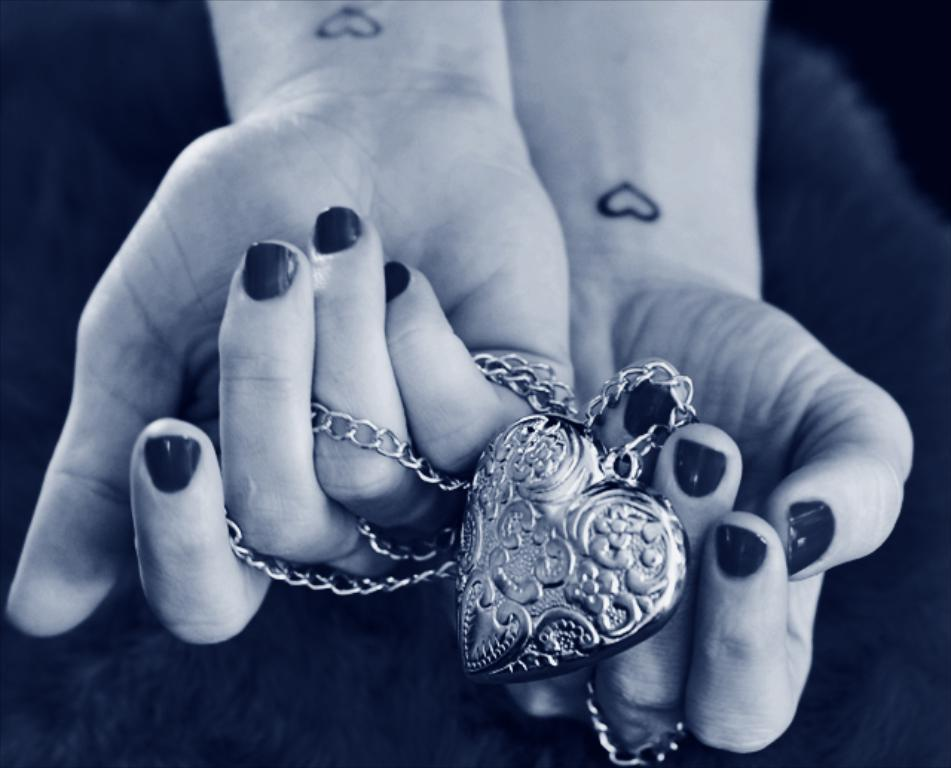What is the person holding in the image? There is a person's hand holding a keychain in the image. What can be observed about the background of the image? The background of the image is dark. What type of wren can be seen singing in the image? There is no wren present in the image, and no singing can be heard or seen. 